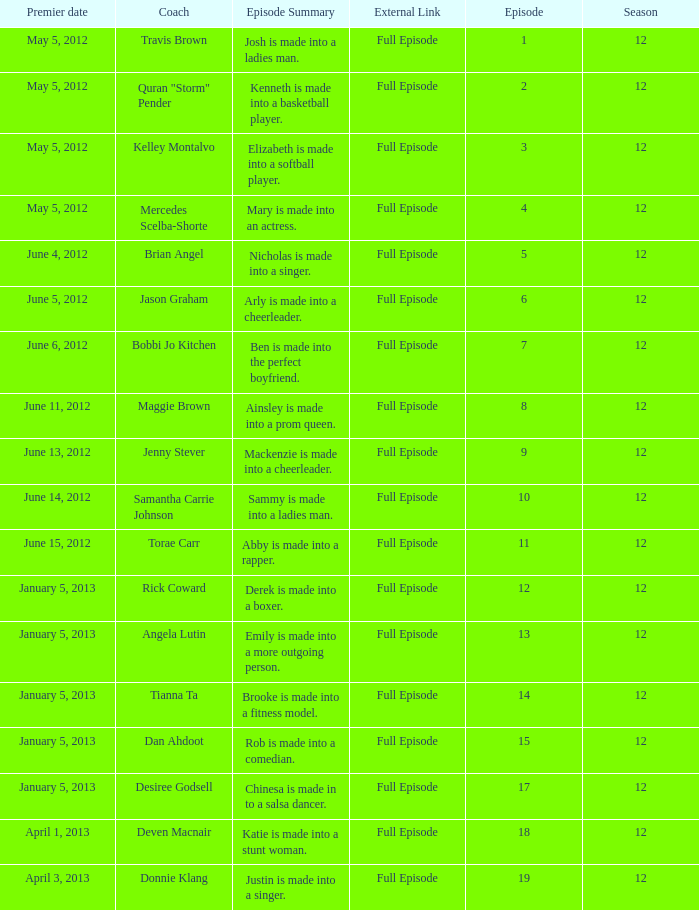Name the episode summary for travis brown Josh is made into a ladies man. 